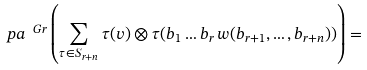Convert formula to latex. <formula><loc_0><loc_0><loc_500><loc_500>\ p a ^ { \ G r } \left ( \sum _ { \tau \in S _ { r + n } } \tau ( v ) \otimes \tau ( b _ { 1 } \dots b _ { r } \, w ( b _ { r + 1 } , \dots , b _ { r + n } ) ) \right ) =</formula> 